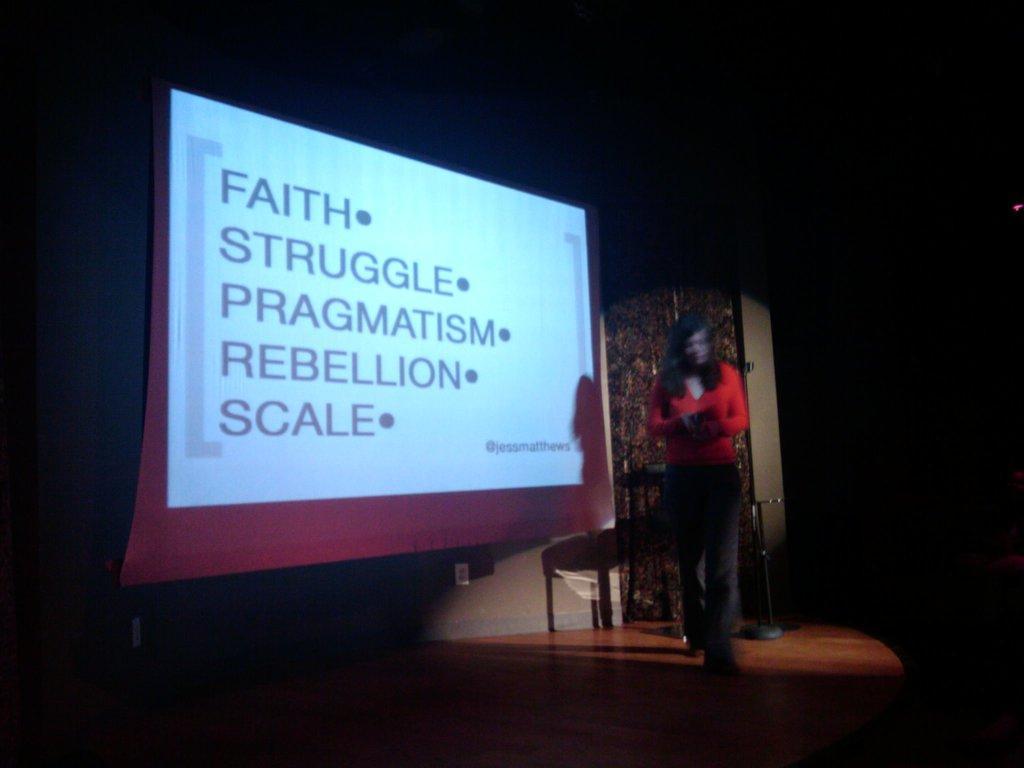Please provide a concise description of this image. In this picture there is a woman who is wearing red t-shirt, jeans and shoes. She is holding a book. She is standing near to the projector screen. Behind her we can see the table and door. On the left we can see the darkness. 